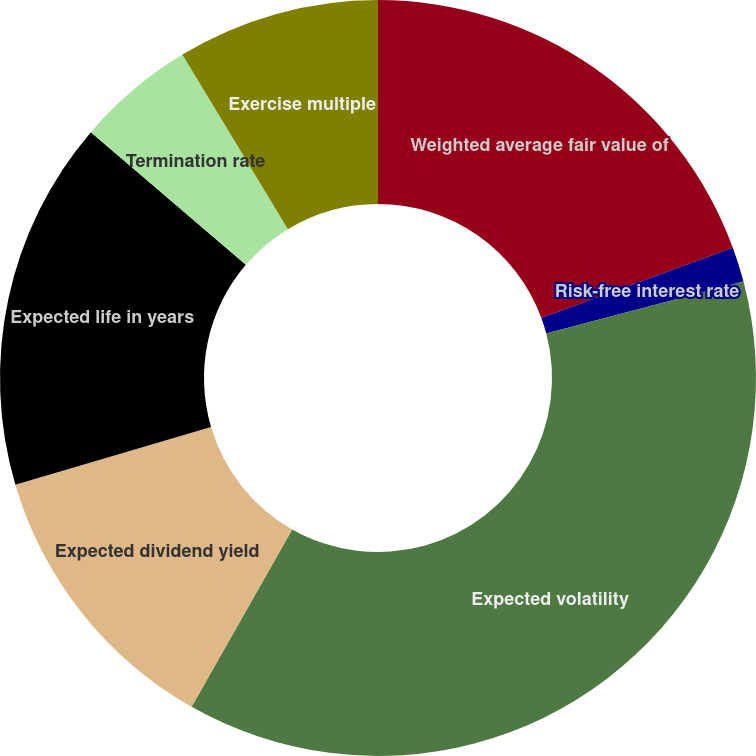Convert chart. <chart><loc_0><loc_0><loc_500><loc_500><pie_chart><fcel>Weighted average fair value of<fcel>Risk-free interest rate<fcel>Expected volatility<fcel>Expected dividend yield<fcel>Expected life in years<fcel>Termination rate<fcel>Exercise multiple<nl><fcel>19.4%<fcel>1.49%<fcel>37.31%<fcel>12.24%<fcel>15.82%<fcel>5.07%<fcel>8.66%<nl></chart> 